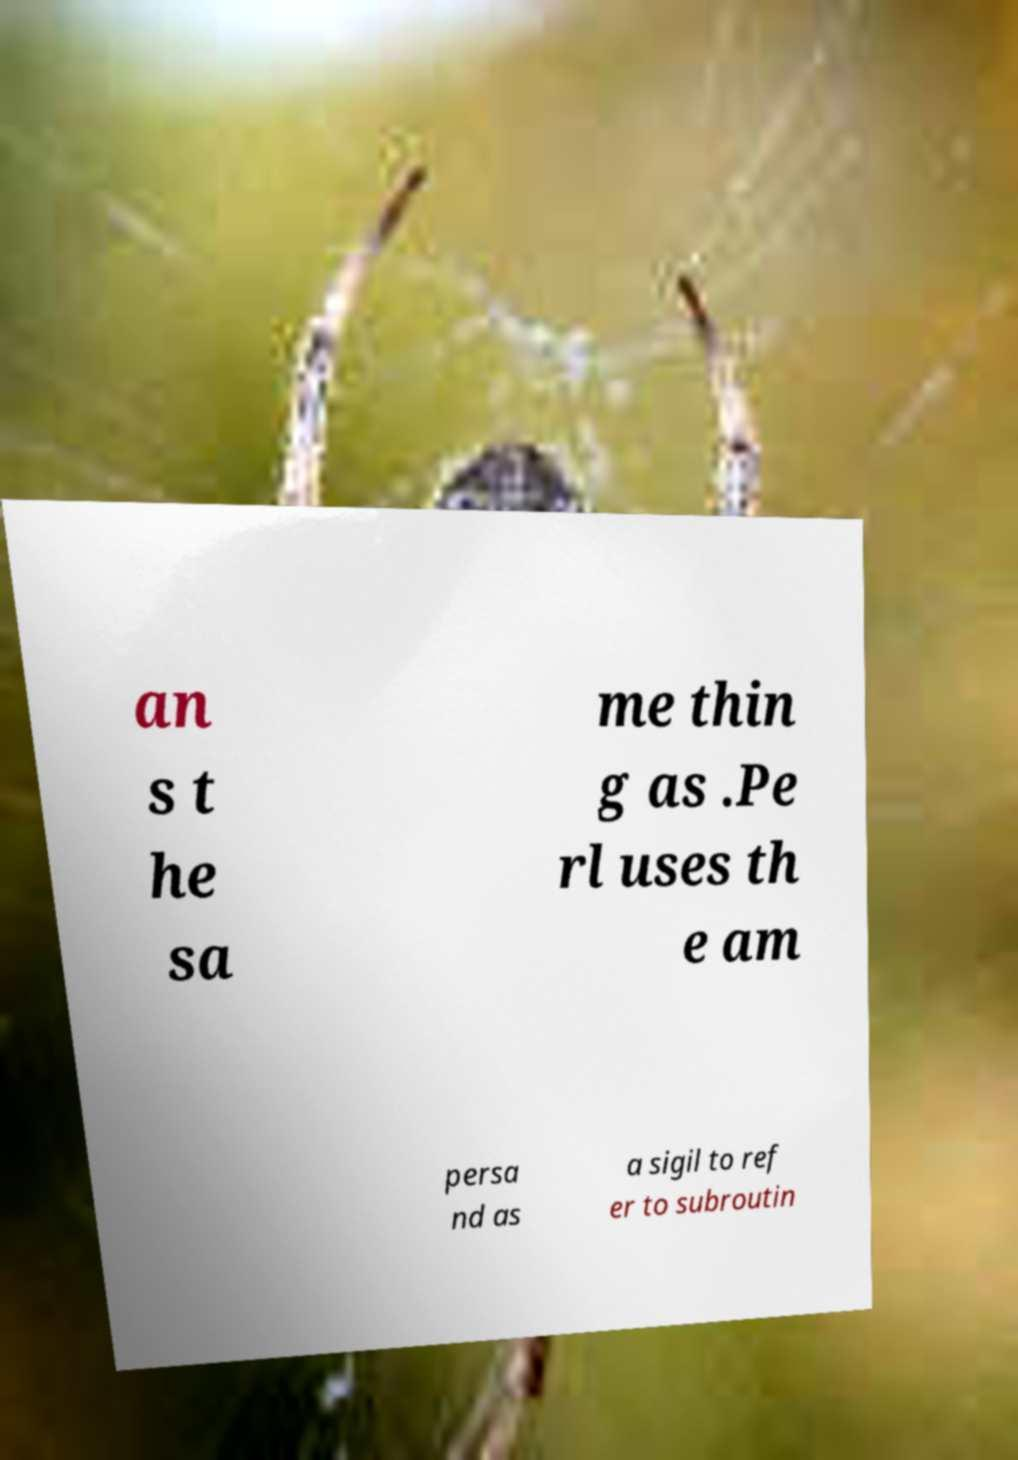There's text embedded in this image that I need extracted. Can you transcribe it verbatim? an s t he sa me thin g as .Pe rl uses th e am persa nd as a sigil to ref er to subroutin 